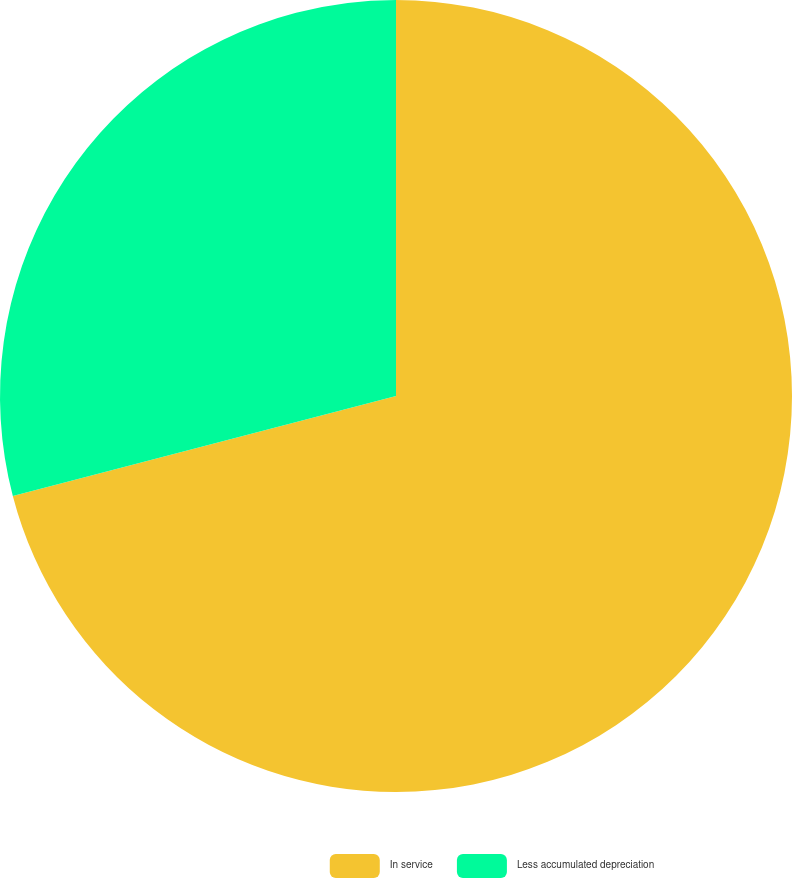Convert chart. <chart><loc_0><loc_0><loc_500><loc_500><pie_chart><fcel>In service<fcel>Less accumulated depreciation<nl><fcel>70.94%<fcel>29.06%<nl></chart> 